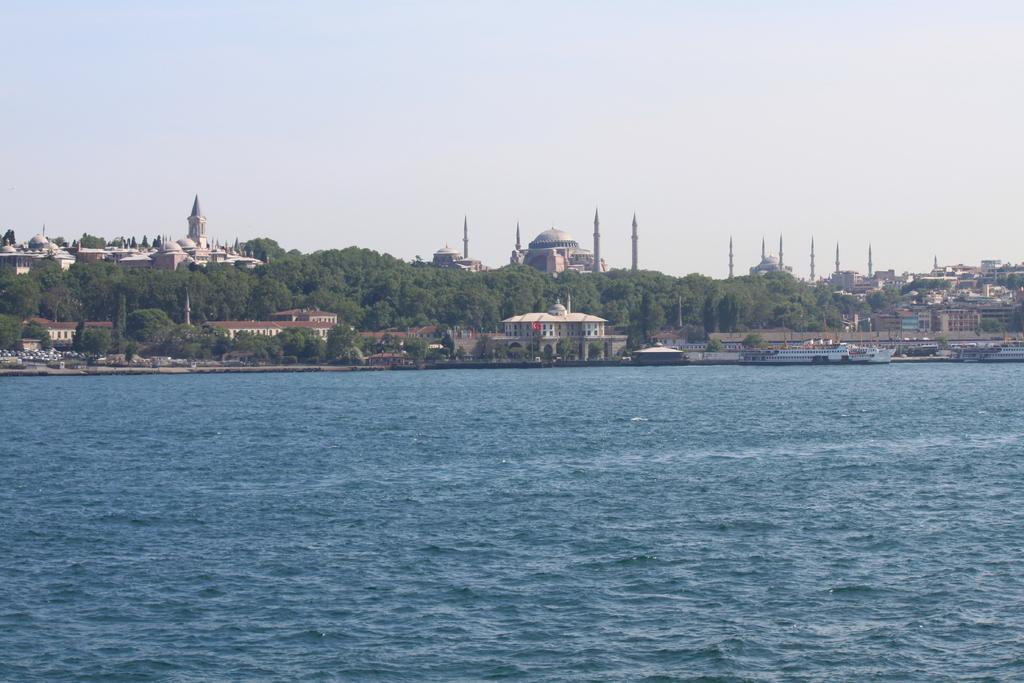What type of water is present in the image? There is blue sea water in the image. What can be seen in the distance behind the sea? There are buildings, trees, and a big mosque with a dome and tower visible in the background. How many bikes are parked near the mosque in the image? There are no bikes present in the image. What type of grain is being harvested in the foreground of the image? There is no grain visible in the image; it features blue sea water and a background with buildings, trees, and a mosque. 